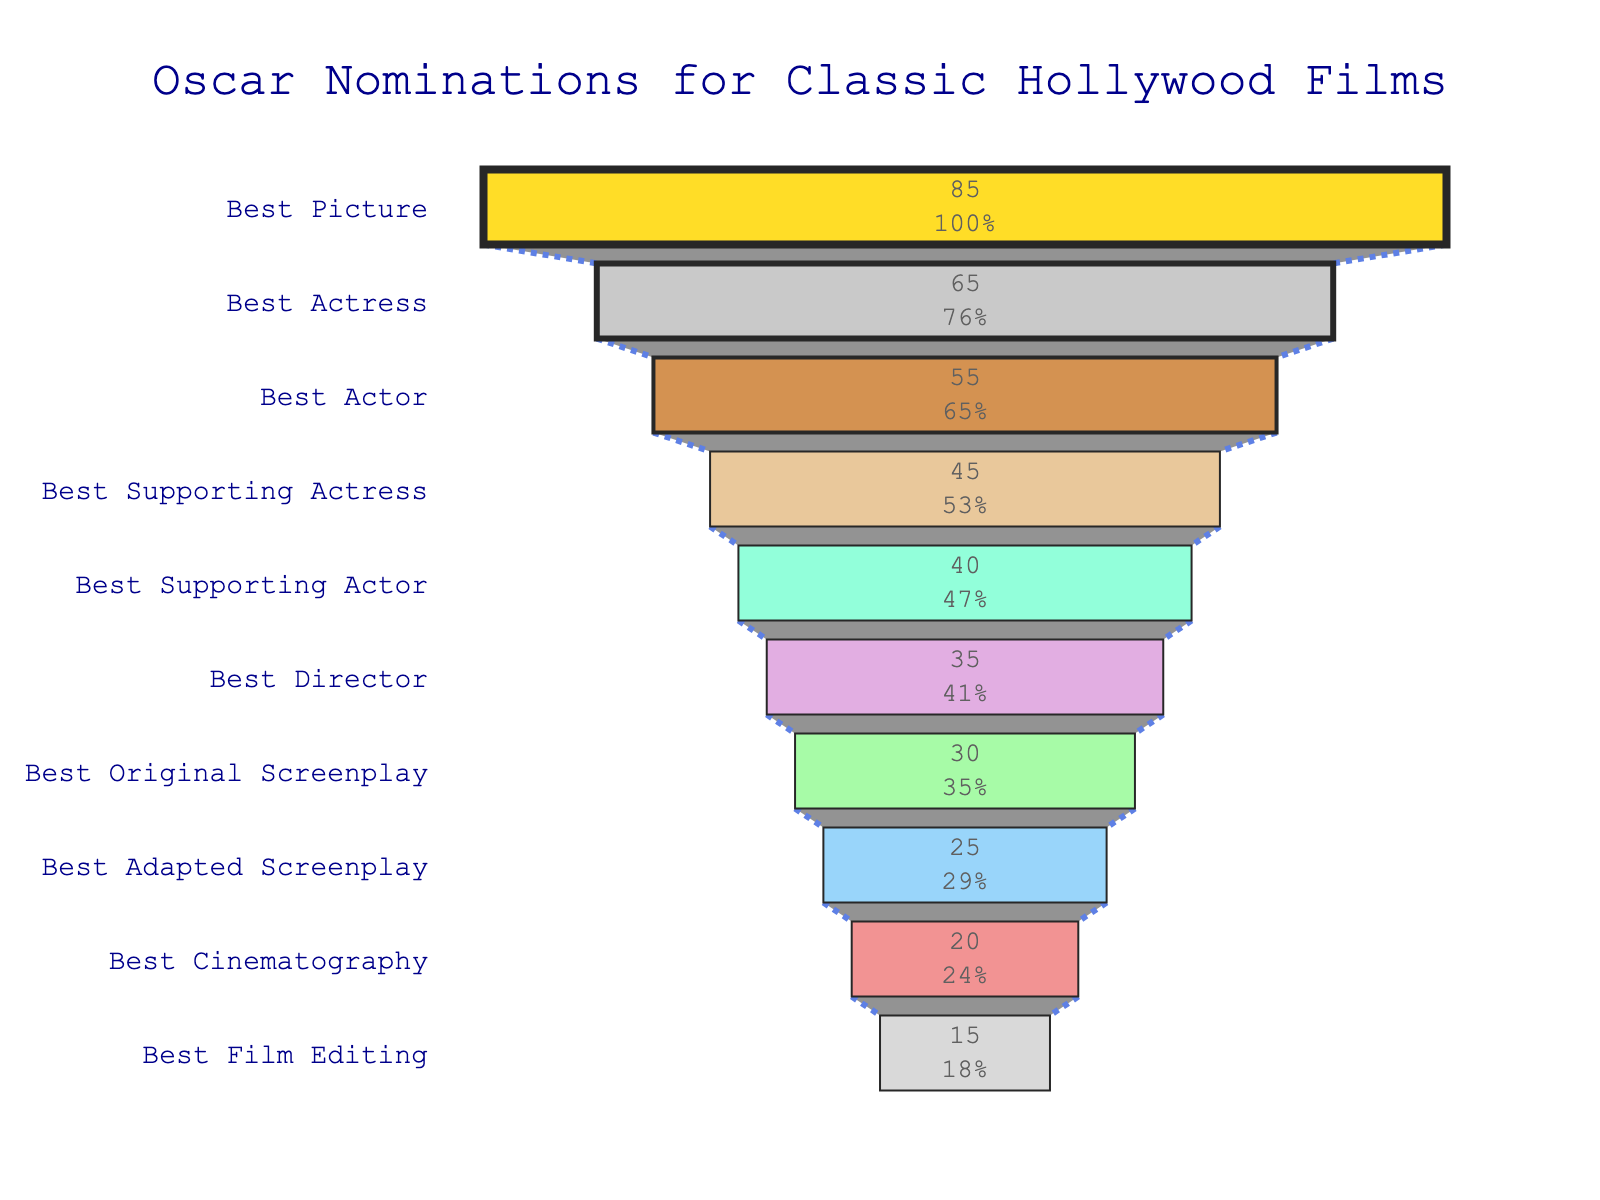What's the title of the chart? The title is typically displayed at the top of the chart. In this case, it is centered and reads "Oscar Nominations for Classic Hollywood Films".
Answer: Oscar Nominations for Classic Hollywood Films How many different award categories are shown? The number of categories corresponds to the number of different bars in the funnel chart. By counting them, we find that there are 10 categories.
Answer: 10 Which category has the highest number of nominations? In a funnel chart, the length of the segment indicates the quantity. The longest segment is for "Best Picture" with 85 nominations.
Answer: Best Picture What percentage of the total nominations does the Best Actress category represent? First, sum all the nominations: 85 + 65 + 55 + 45 + 40 + 35 + 30 + 25 + 20 + 15 = 415. Then, calculate the percentage for Best Actress: (65 / 415) * 100 ≈ 15.66%.
Answer: 15.66% What is the sum of nominations for both acting categories (Best Actor and Best Actress)? Add the nominations for Best Actor (55) and Best Actress (65): 55 + 65 = 120.
Answer: 120 Compare the total nominations for the Best Supporting Actress category to the Best Supporting Actor category. Which has more and by how many? Subtract nominations for Best Supporting Actor (40) from those for Best Supporting Actress (45): 45 - 40 = 5.
Answer: Best Supporting Actress by 5 What is the median number of nominations across all categories? Sort the nominations: 15, 20, 25, 30, 35, 40, 45, 55, 65, 85. As there are 10 categories, the median is the average of the 5th and 6th values (35 and 40): (35 + 40) / 2 = 37.5.
Answer: 37.5 By how many nominations does Best Picture exceed Best Actor? Subtract Best Actor's nominations (55) from Best Picture's (85): 85 - 55 = 30.
Answer: 30 What's the difference between the total nominations for screenplay categories (Best Original Screenplay and Best Adapted Screenplay)? Add the nominations for both categories first: 30 (Original) + 25 (Adapted) = 55. Then subtract them: 30 - 25 = 5.
Answer: 5 How many categories have fewer than 40 nominations? Identify the categories with nominations less than 40: Best Director (35), Best Original Screenplay (30), Best Adapted Screenplay (25), Best Cinematography (20), Best Film Editing (15). There are 5 such categories.
Answer: 5 